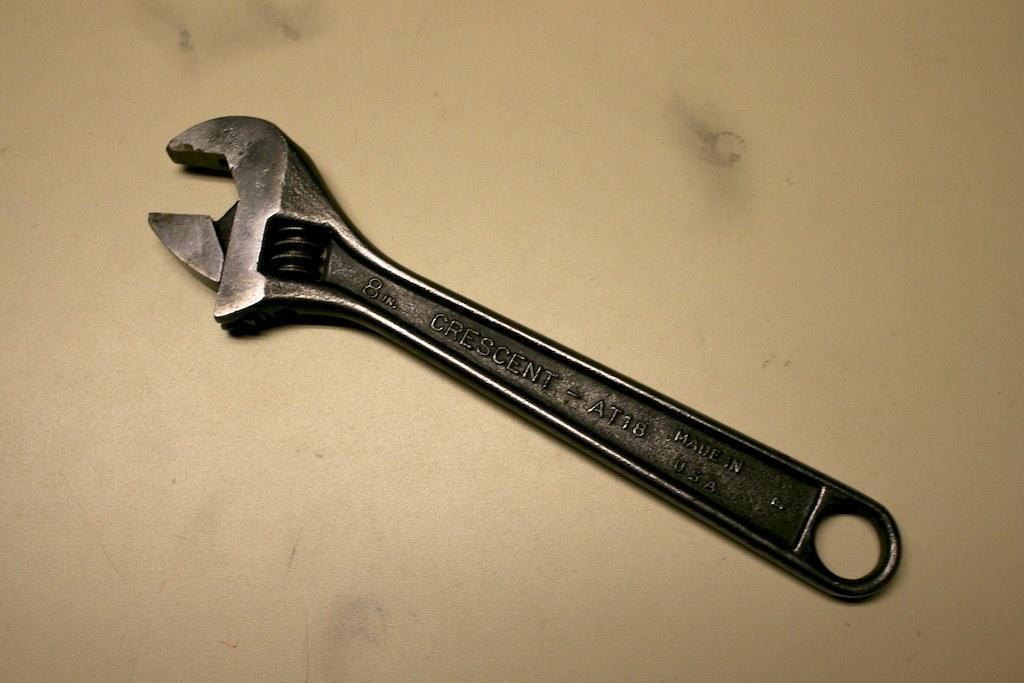Can you describe this image briefly? In this picture there is a wrench which is kept on the table. 